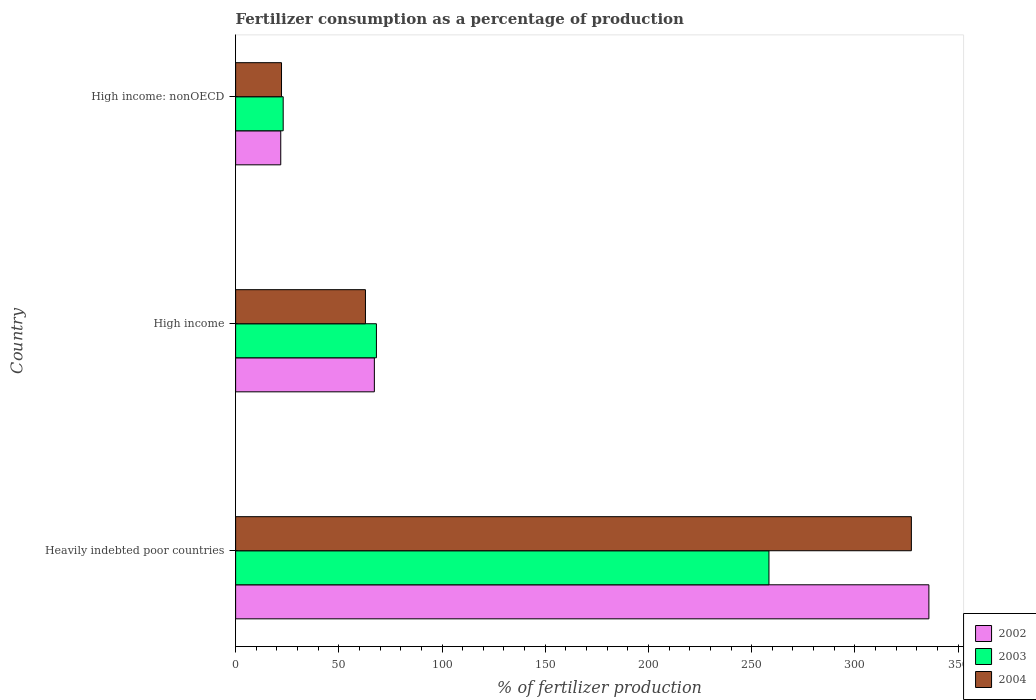How many groups of bars are there?
Provide a succinct answer. 3. How many bars are there on the 2nd tick from the bottom?
Make the answer very short. 3. What is the label of the 1st group of bars from the top?
Offer a very short reply. High income: nonOECD. What is the percentage of fertilizers consumed in 2004 in Heavily indebted poor countries?
Offer a very short reply. 327.38. Across all countries, what is the maximum percentage of fertilizers consumed in 2003?
Give a very brief answer. 258.39. Across all countries, what is the minimum percentage of fertilizers consumed in 2003?
Provide a short and direct response. 23.04. In which country was the percentage of fertilizers consumed in 2003 maximum?
Ensure brevity in your answer.  Heavily indebted poor countries. In which country was the percentage of fertilizers consumed in 2004 minimum?
Make the answer very short. High income: nonOECD. What is the total percentage of fertilizers consumed in 2002 in the graph?
Offer a terse response. 424.96. What is the difference between the percentage of fertilizers consumed in 2003 in Heavily indebted poor countries and that in High income: nonOECD?
Your response must be concise. 235.35. What is the difference between the percentage of fertilizers consumed in 2003 in High income and the percentage of fertilizers consumed in 2002 in High income: nonOECD?
Offer a terse response. 46.35. What is the average percentage of fertilizers consumed in 2002 per country?
Make the answer very short. 141.65. What is the difference between the percentage of fertilizers consumed in 2002 and percentage of fertilizers consumed in 2003 in High income?
Your answer should be compact. -0.99. In how many countries, is the percentage of fertilizers consumed in 2004 greater than 60 %?
Make the answer very short. 2. What is the ratio of the percentage of fertilizers consumed in 2003 in Heavily indebted poor countries to that in High income?
Your answer should be very brief. 3.79. Is the difference between the percentage of fertilizers consumed in 2002 in Heavily indebted poor countries and High income greater than the difference between the percentage of fertilizers consumed in 2003 in Heavily indebted poor countries and High income?
Provide a succinct answer. Yes. What is the difference between the highest and the second highest percentage of fertilizers consumed in 2003?
Make the answer very short. 190.18. What is the difference between the highest and the lowest percentage of fertilizers consumed in 2004?
Provide a short and direct response. 305.14. Is the sum of the percentage of fertilizers consumed in 2002 in Heavily indebted poor countries and High income: nonOECD greater than the maximum percentage of fertilizers consumed in 2003 across all countries?
Give a very brief answer. Yes. What does the 3rd bar from the bottom in High income represents?
Give a very brief answer. 2004. What is the difference between two consecutive major ticks on the X-axis?
Your answer should be very brief. 50. Are the values on the major ticks of X-axis written in scientific E-notation?
Offer a terse response. No. Where does the legend appear in the graph?
Keep it short and to the point. Bottom right. How many legend labels are there?
Keep it short and to the point. 3. How are the legend labels stacked?
Make the answer very short. Vertical. What is the title of the graph?
Keep it short and to the point. Fertilizer consumption as a percentage of production. Does "2006" appear as one of the legend labels in the graph?
Your response must be concise. No. What is the label or title of the X-axis?
Make the answer very short. % of fertilizer production. What is the % of fertilizer production in 2002 in Heavily indebted poor countries?
Ensure brevity in your answer.  335.87. What is the % of fertilizer production of 2003 in Heavily indebted poor countries?
Keep it short and to the point. 258.39. What is the % of fertilizer production of 2004 in Heavily indebted poor countries?
Provide a short and direct response. 327.38. What is the % of fertilizer production in 2002 in High income?
Your answer should be very brief. 67.22. What is the % of fertilizer production in 2003 in High income?
Your response must be concise. 68.21. What is the % of fertilizer production of 2004 in High income?
Give a very brief answer. 62.91. What is the % of fertilizer production in 2002 in High income: nonOECD?
Offer a very short reply. 21.86. What is the % of fertilizer production in 2003 in High income: nonOECD?
Make the answer very short. 23.04. What is the % of fertilizer production in 2004 in High income: nonOECD?
Ensure brevity in your answer.  22.24. Across all countries, what is the maximum % of fertilizer production of 2002?
Make the answer very short. 335.87. Across all countries, what is the maximum % of fertilizer production in 2003?
Offer a very short reply. 258.39. Across all countries, what is the maximum % of fertilizer production in 2004?
Your answer should be very brief. 327.38. Across all countries, what is the minimum % of fertilizer production of 2002?
Give a very brief answer. 21.86. Across all countries, what is the minimum % of fertilizer production in 2003?
Offer a very short reply. 23.04. Across all countries, what is the minimum % of fertilizer production in 2004?
Your response must be concise. 22.24. What is the total % of fertilizer production of 2002 in the graph?
Offer a very short reply. 424.96. What is the total % of fertilizer production of 2003 in the graph?
Make the answer very short. 349.64. What is the total % of fertilizer production in 2004 in the graph?
Offer a terse response. 412.53. What is the difference between the % of fertilizer production of 2002 in Heavily indebted poor countries and that in High income?
Make the answer very short. 268.65. What is the difference between the % of fertilizer production of 2003 in Heavily indebted poor countries and that in High income?
Your answer should be compact. 190.18. What is the difference between the % of fertilizer production in 2004 in Heavily indebted poor countries and that in High income?
Make the answer very short. 264.48. What is the difference between the % of fertilizer production in 2002 in Heavily indebted poor countries and that in High income: nonOECD?
Your answer should be compact. 314.01. What is the difference between the % of fertilizer production in 2003 in Heavily indebted poor countries and that in High income: nonOECD?
Offer a very short reply. 235.35. What is the difference between the % of fertilizer production of 2004 in Heavily indebted poor countries and that in High income: nonOECD?
Your answer should be compact. 305.14. What is the difference between the % of fertilizer production in 2002 in High income and that in High income: nonOECD?
Offer a terse response. 45.36. What is the difference between the % of fertilizer production in 2003 in High income and that in High income: nonOECD?
Ensure brevity in your answer.  45.17. What is the difference between the % of fertilizer production of 2004 in High income and that in High income: nonOECD?
Offer a very short reply. 40.67. What is the difference between the % of fertilizer production in 2002 in Heavily indebted poor countries and the % of fertilizer production in 2003 in High income?
Make the answer very short. 267.66. What is the difference between the % of fertilizer production in 2002 in Heavily indebted poor countries and the % of fertilizer production in 2004 in High income?
Your answer should be compact. 272.97. What is the difference between the % of fertilizer production of 2003 in Heavily indebted poor countries and the % of fertilizer production of 2004 in High income?
Offer a terse response. 195.48. What is the difference between the % of fertilizer production in 2002 in Heavily indebted poor countries and the % of fertilizer production in 2003 in High income: nonOECD?
Your answer should be compact. 312.83. What is the difference between the % of fertilizer production of 2002 in Heavily indebted poor countries and the % of fertilizer production of 2004 in High income: nonOECD?
Make the answer very short. 313.63. What is the difference between the % of fertilizer production in 2003 in Heavily indebted poor countries and the % of fertilizer production in 2004 in High income: nonOECD?
Provide a short and direct response. 236.15. What is the difference between the % of fertilizer production in 2002 in High income and the % of fertilizer production in 2003 in High income: nonOECD?
Give a very brief answer. 44.18. What is the difference between the % of fertilizer production in 2002 in High income and the % of fertilizer production in 2004 in High income: nonOECD?
Give a very brief answer. 44.98. What is the difference between the % of fertilizer production of 2003 in High income and the % of fertilizer production of 2004 in High income: nonOECD?
Your answer should be compact. 45.97. What is the average % of fertilizer production of 2002 per country?
Provide a short and direct response. 141.65. What is the average % of fertilizer production in 2003 per country?
Provide a succinct answer. 116.55. What is the average % of fertilizer production in 2004 per country?
Ensure brevity in your answer.  137.51. What is the difference between the % of fertilizer production of 2002 and % of fertilizer production of 2003 in Heavily indebted poor countries?
Keep it short and to the point. 77.48. What is the difference between the % of fertilizer production of 2002 and % of fertilizer production of 2004 in Heavily indebted poor countries?
Make the answer very short. 8.49. What is the difference between the % of fertilizer production of 2003 and % of fertilizer production of 2004 in Heavily indebted poor countries?
Offer a terse response. -68.99. What is the difference between the % of fertilizer production of 2002 and % of fertilizer production of 2003 in High income?
Keep it short and to the point. -0.99. What is the difference between the % of fertilizer production in 2002 and % of fertilizer production in 2004 in High income?
Provide a succinct answer. 4.31. What is the difference between the % of fertilizer production of 2003 and % of fertilizer production of 2004 in High income?
Offer a terse response. 5.31. What is the difference between the % of fertilizer production in 2002 and % of fertilizer production in 2003 in High income: nonOECD?
Your answer should be compact. -1.18. What is the difference between the % of fertilizer production in 2002 and % of fertilizer production in 2004 in High income: nonOECD?
Offer a very short reply. -0.38. What is the difference between the % of fertilizer production of 2003 and % of fertilizer production of 2004 in High income: nonOECD?
Your response must be concise. 0.8. What is the ratio of the % of fertilizer production in 2002 in Heavily indebted poor countries to that in High income?
Offer a very short reply. 5. What is the ratio of the % of fertilizer production in 2003 in Heavily indebted poor countries to that in High income?
Offer a very short reply. 3.79. What is the ratio of the % of fertilizer production in 2004 in Heavily indebted poor countries to that in High income?
Your response must be concise. 5.2. What is the ratio of the % of fertilizer production in 2002 in Heavily indebted poor countries to that in High income: nonOECD?
Make the answer very short. 15.36. What is the ratio of the % of fertilizer production of 2003 in Heavily indebted poor countries to that in High income: nonOECD?
Your answer should be very brief. 11.21. What is the ratio of the % of fertilizer production in 2004 in Heavily indebted poor countries to that in High income: nonOECD?
Give a very brief answer. 14.72. What is the ratio of the % of fertilizer production in 2002 in High income to that in High income: nonOECD?
Your response must be concise. 3.07. What is the ratio of the % of fertilizer production of 2003 in High income to that in High income: nonOECD?
Make the answer very short. 2.96. What is the ratio of the % of fertilizer production of 2004 in High income to that in High income: nonOECD?
Give a very brief answer. 2.83. What is the difference between the highest and the second highest % of fertilizer production in 2002?
Keep it short and to the point. 268.65. What is the difference between the highest and the second highest % of fertilizer production of 2003?
Your answer should be compact. 190.18. What is the difference between the highest and the second highest % of fertilizer production in 2004?
Make the answer very short. 264.48. What is the difference between the highest and the lowest % of fertilizer production in 2002?
Provide a short and direct response. 314.01. What is the difference between the highest and the lowest % of fertilizer production in 2003?
Your answer should be compact. 235.35. What is the difference between the highest and the lowest % of fertilizer production of 2004?
Provide a succinct answer. 305.14. 